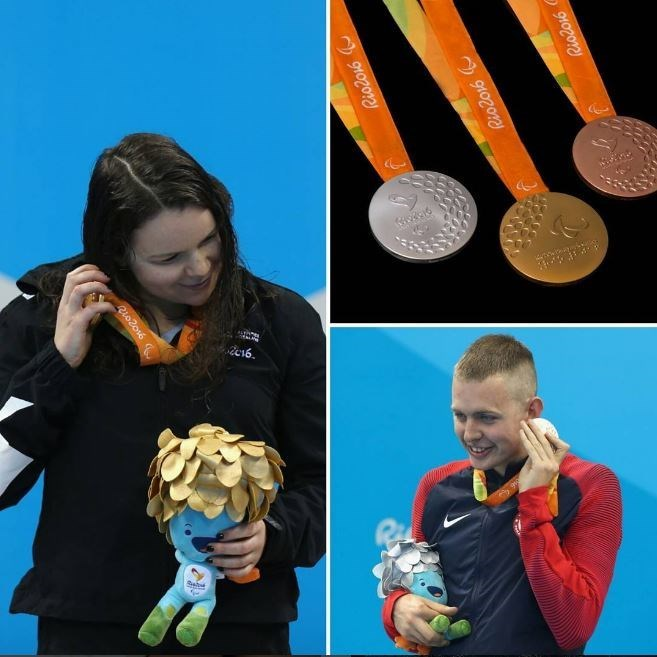How do the Rio 2016 Olympic medals differ in appearance and significance compared to previous Olympic medals? The Rio 2016 Olympic medals are distinct in both their appearance and significance. Designed with sustainability in mind, these medals incorporated recycled materials—the gold medals, for example, were made without the use of mercury, and the silver and bronze medals included recycled materials. The design features the Rio 2016 logo along with laurel leaves, symbolizing victory and honor. Compared to previous Olympic medals, the Rio 2016 medals also focused on their environmental footprint, reflecting a growing awareness and commitment to sustainability in global events. The unique design and symbolic effort towards environmental responsibility make these medals stand out as iconic souvenirs of the 2016 Games. 